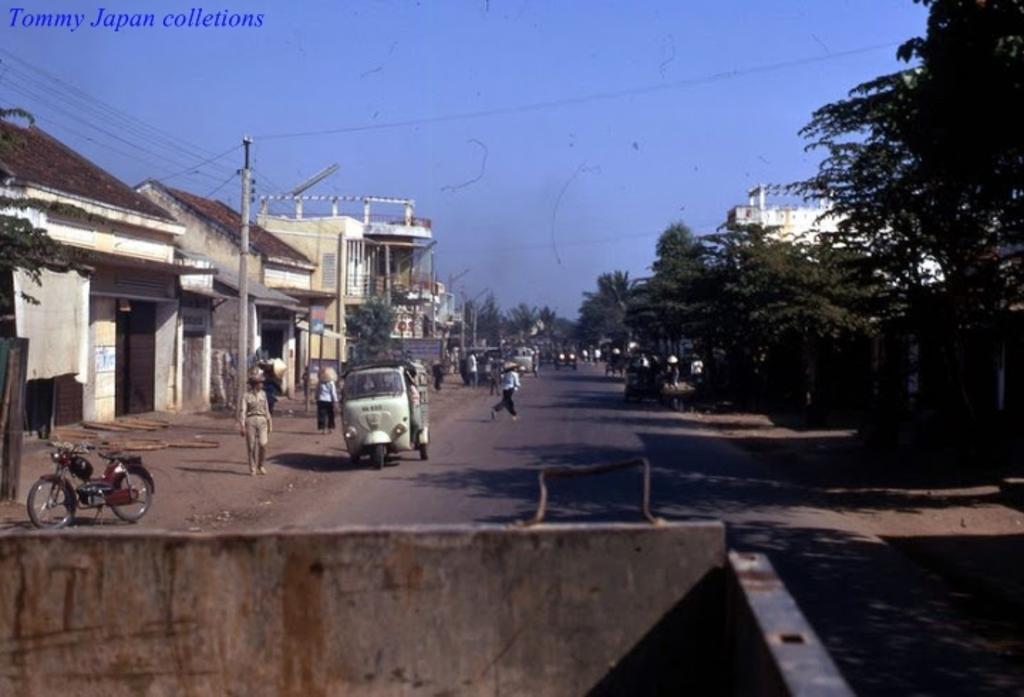Describe this image in one or two sentences. In this image on the right side there are trees and there is a building. On the left side there are buildings, persons and poles and there are vehicles and there is a tree. In the background there are trees and there are vehicles and there are persons and there are wires on the left side. 